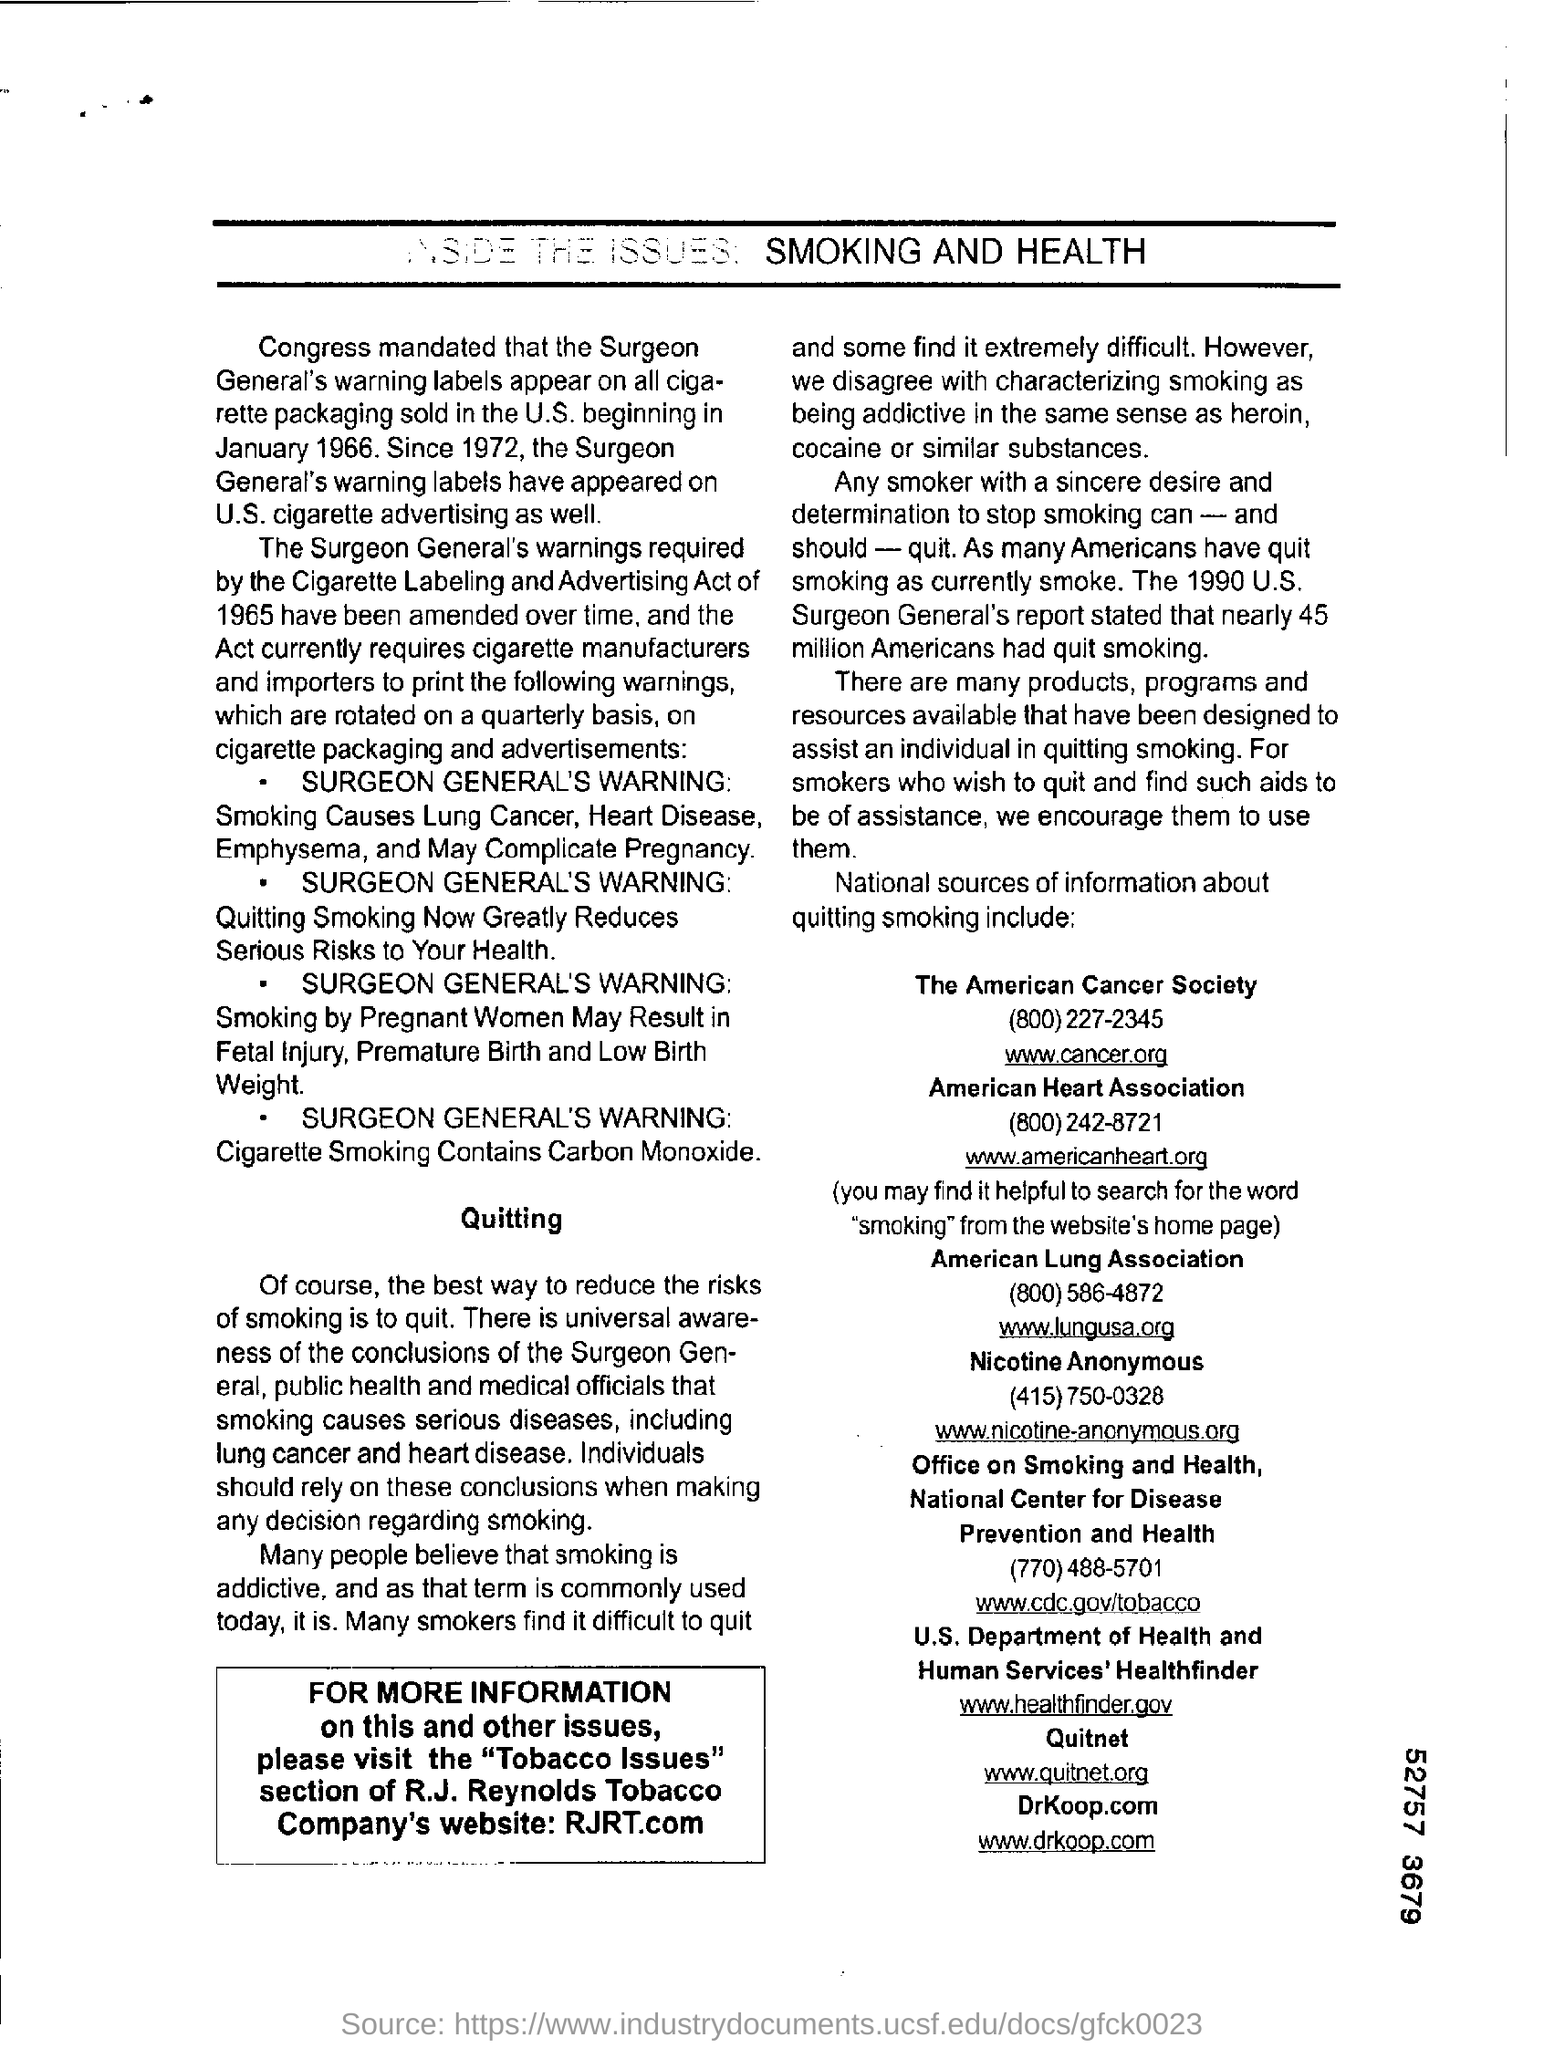What is the mail id of american cancer society?
Ensure brevity in your answer.  Www.cancer.org. What is the contact number of the american cancer society?
Your answer should be very brief. (800)227-2345. What is the mail id of american heart association?
Offer a terse response. Www.americanheart.org. 